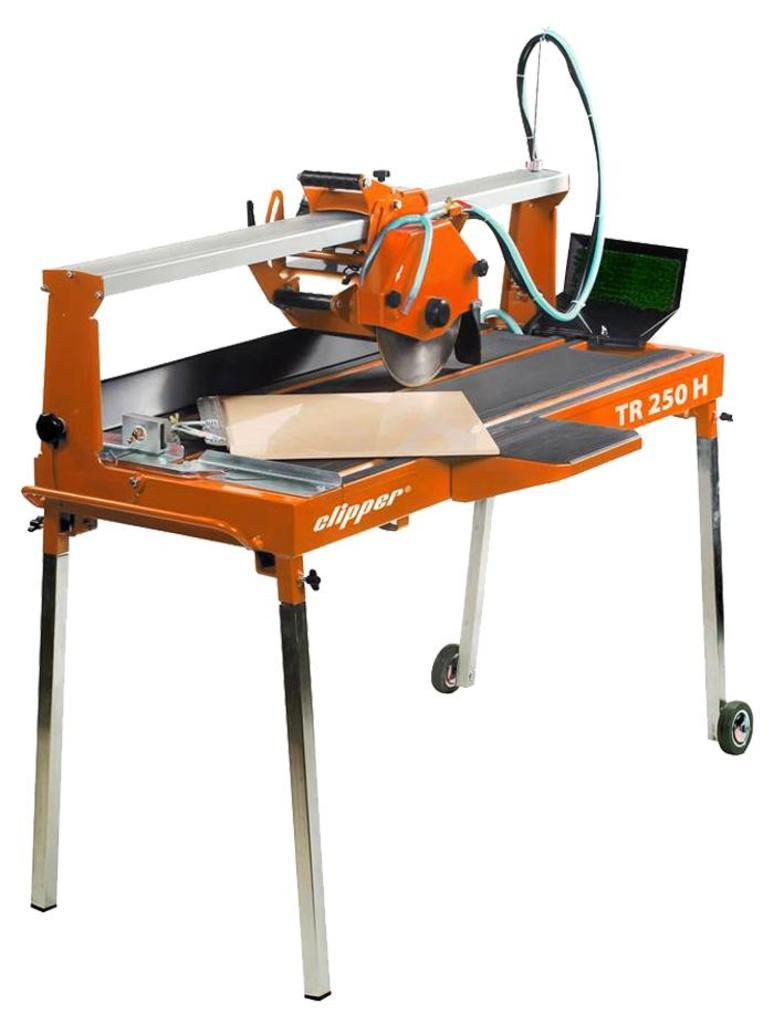What is the main subject of the image? The main subject of the image is a machine. Can you describe the colors of the machine? The machine has orange, grey, green, and white colors. What is the color of the background in the image? The background of the image is white. How many rings are visible on the machine in the image? There are no rings visible on the machine in the image. Is there a book on the machine in the image? There is no book present in the image. 